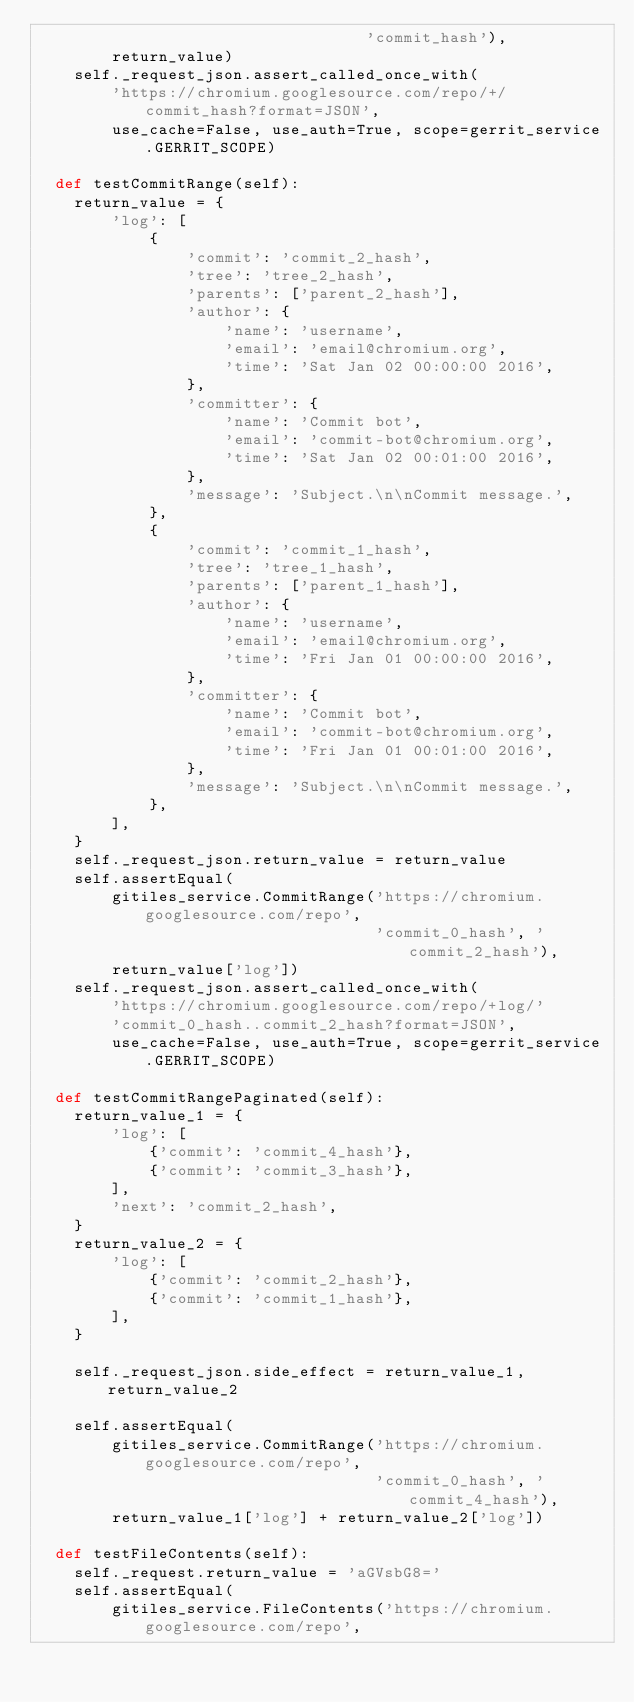Convert code to text. <code><loc_0><loc_0><loc_500><loc_500><_Python_>                                   'commit_hash'),
        return_value)
    self._request_json.assert_called_once_with(
        'https://chromium.googlesource.com/repo/+/commit_hash?format=JSON',
        use_cache=False, use_auth=True, scope=gerrit_service.GERRIT_SCOPE)

  def testCommitRange(self):
    return_value = {
        'log': [
            {
                'commit': 'commit_2_hash',
                'tree': 'tree_2_hash',
                'parents': ['parent_2_hash'],
                'author': {
                    'name': 'username',
                    'email': 'email@chromium.org',
                    'time': 'Sat Jan 02 00:00:00 2016',
                },
                'committer': {
                    'name': 'Commit bot',
                    'email': 'commit-bot@chromium.org',
                    'time': 'Sat Jan 02 00:01:00 2016',
                },
                'message': 'Subject.\n\nCommit message.',
            },
            {
                'commit': 'commit_1_hash',
                'tree': 'tree_1_hash',
                'parents': ['parent_1_hash'],
                'author': {
                    'name': 'username',
                    'email': 'email@chromium.org',
                    'time': 'Fri Jan 01 00:00:00 2016',
                },
                'committer': {
                    'name': 'Commit bot',
                    'email': 'commit-bot@chromium.org',
                    'time': 'Fri Jan 01 00:01:00 2016',
                },
                'message': 'Subject.\n\nCommit message.',
            },
        ],
    }
    self._request_json.return_value = return_value
    self.assertEqual(
        gitiles_service.CommitRange('https://chromium.googlesource.com/repo',
                                    'commit_0_hash', 'commit_2_hash'),
        return_value['log'])
    self._request_json.assert_called_once_with(
        'https://chromium.googlesource.com/repo/+log/'
        'commit_0_hash..commit_2_hash?format=JSON',
        use_cache=False, use_auth=True, scope=gerrit_service.GERRIT_SCOPE)

  def testCommitRangePaginated(self):
    return_value_1 = {
        'log': [
            {'commit': 'commit_4_hash'},
            {'commit': 'commit_3_hash'},
        ],
        'next': 'commit_2_hash',
    }
    return_value_2 = {
        'log': [
            {'commit': 'commit_2_hash'},
            {'commit': 'commit_1_hash'},
        ],
    }

    self._request_json.side_effect = return_value_1, return_value_2

    self.assertEqual(
        gitiles_service.CommitRange('https://chromium.googlesource.com/repo',
                                    'commit_0_hash', 'commit_4_hash'),
        return_value_1['log'] + return_value_2['log'])

  def testFileContents(self):
    self._request.return_value = 'aGVsbG8='
    self.assertEqual(
        gitiles_service.FileContents('https://chromium.googlesource.com/repo',</code> 